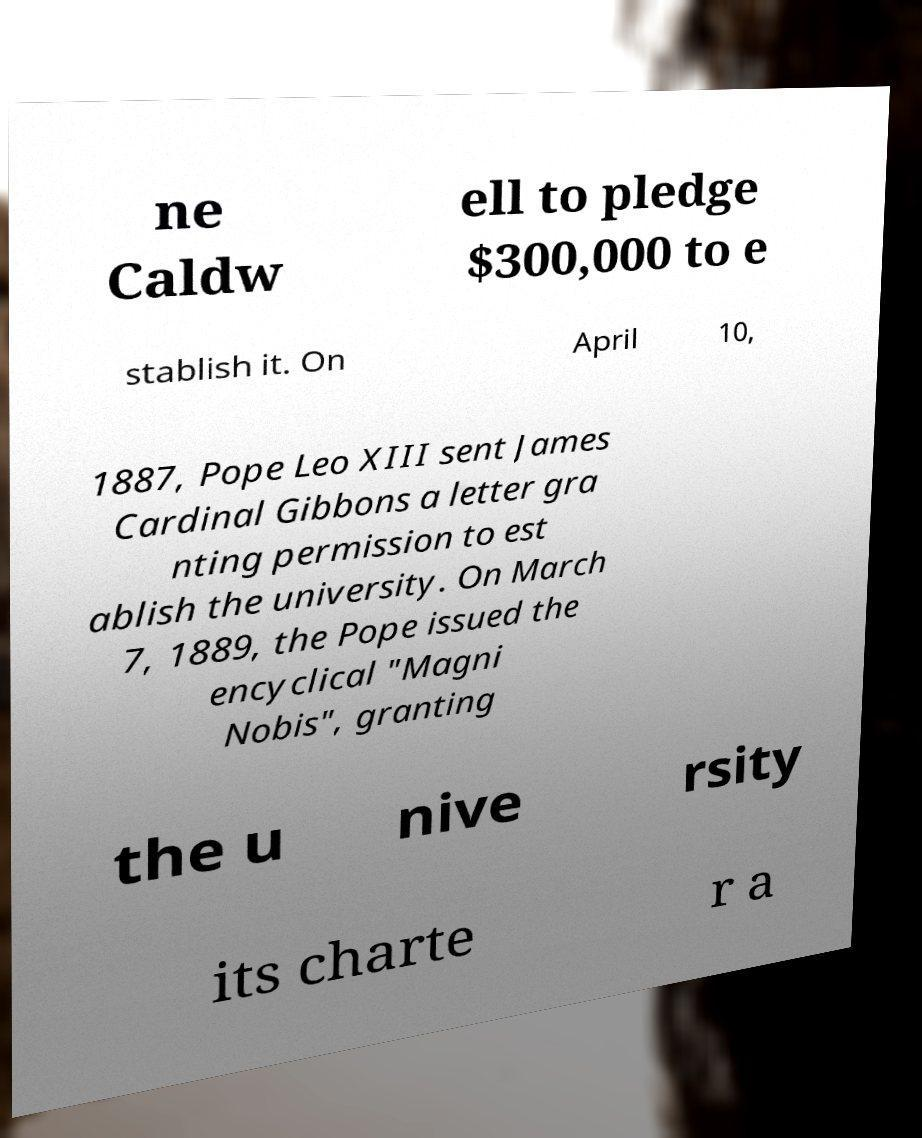Please read and relay the text visible in this image. What does it say? ne Caldw ell to pledge $300,000 to e stablish it. On April 10, 1887, Pope Leo XIII sent James Cardinal Gibbons a letter gra nting permission to est ablish the university. On March 7, 1889, the Pope issued the encyclical "Magni Nobis", granting the u nive rsity its charte r a 